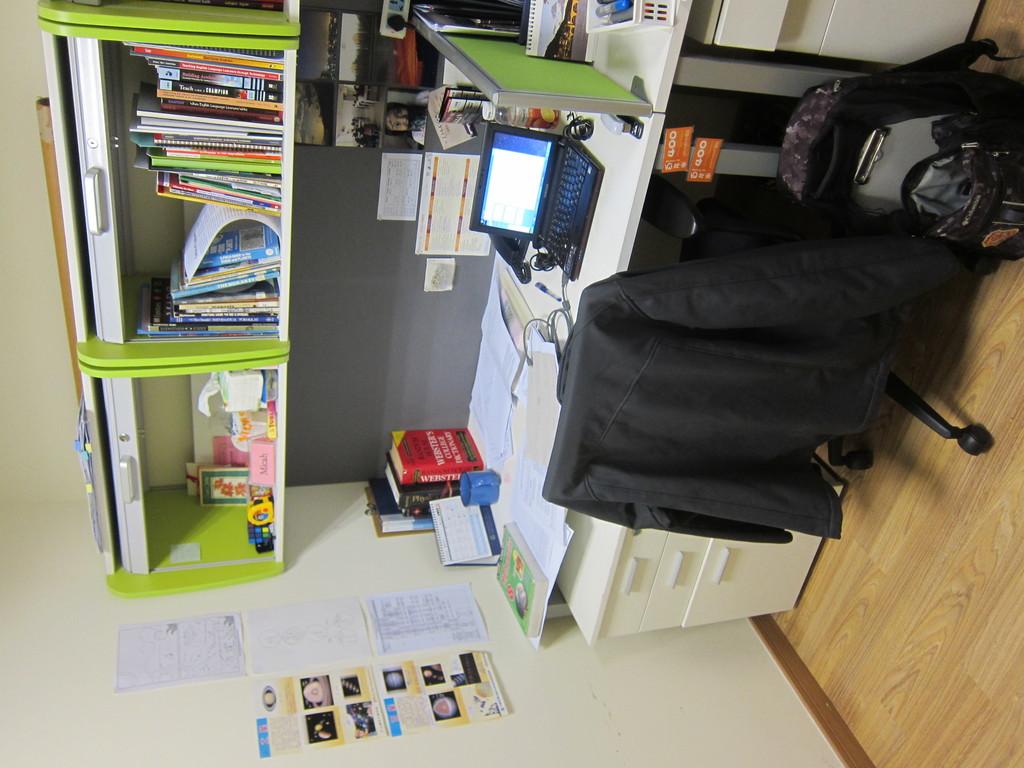What is the title of the red book on the desk?
Your answer should be compact. Unanswerable. Is this a paint ?
Give a very brief answer. No. 